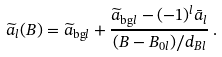<formula> <loc_0><loc_0><loc_500><loc_500>\widetilde { a } _ { l } ( B ) = \widetilde { a } _ { \text {bg} l } + \frac { \widetilde { a } _ { \text {bg} l } - ( - 1 ) ^ { l } \bar { a } _ { l } } { ( B - B _ { 0 l } ) / d _ { B l } } \, .</formula> 